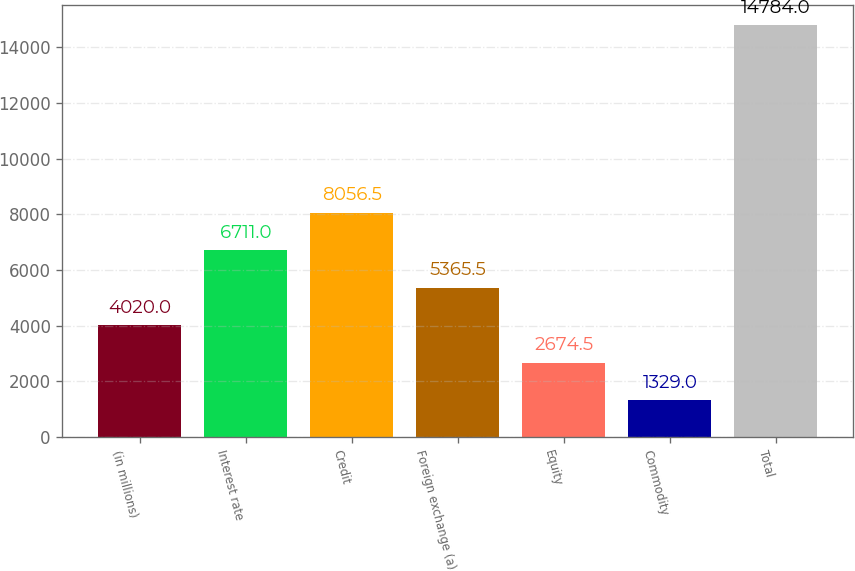Convert chart. <chart><loc_0><loc_0><loc_500><loc_500><bar_chart><fcel>(in millions)<fcel>Interest rate<fcel>Credit<fcel>Foreign exchange (a)<fcel>Equity<fcel>Commodity<fcel>Total<nl><fcel>4020<fcel>6711<fcel>8056.5<fcel>5365.5<fcel>2674.5<fcel>1329<fcel>14784<nl></chart> 